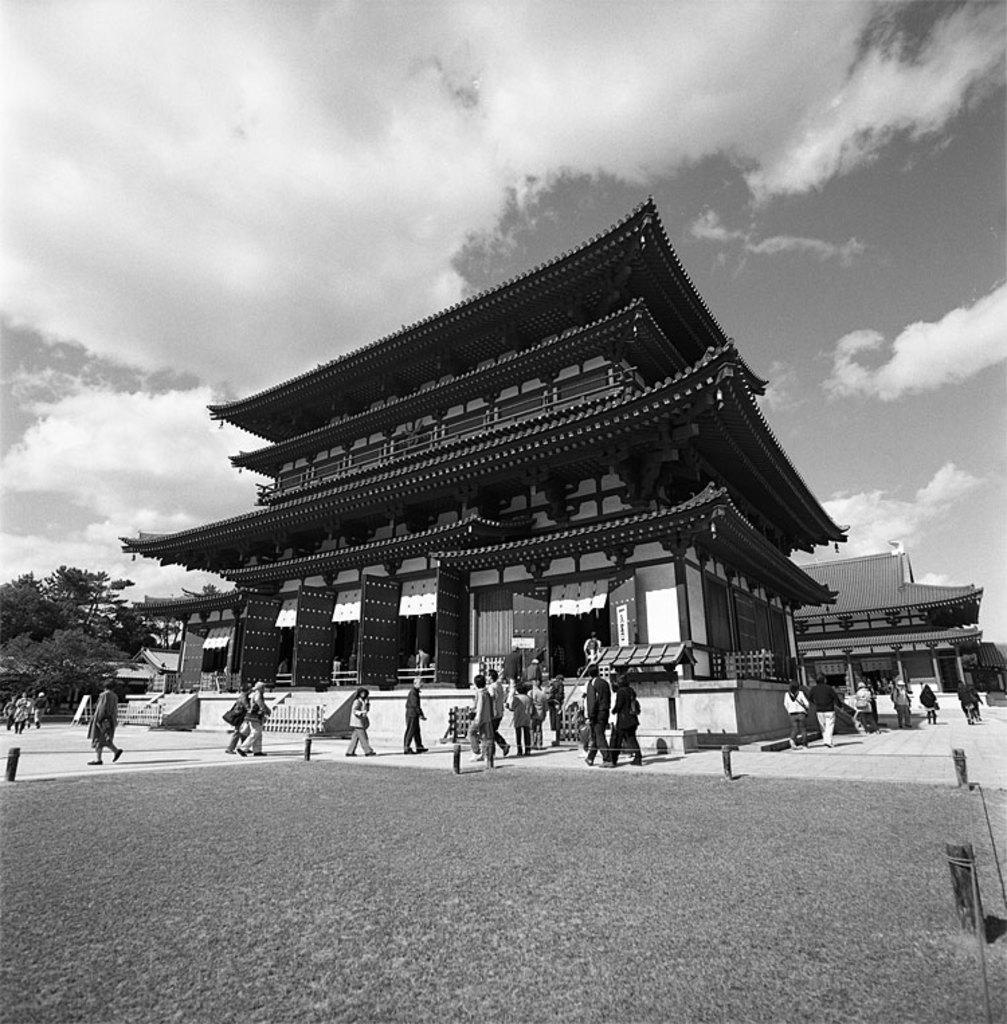Please provide a concise description of this image. This is a black and white image. Here I can see some buildings and trees. In front of this building there are few people walking on the ground. On the top of the image I can see the sky and clouds. 